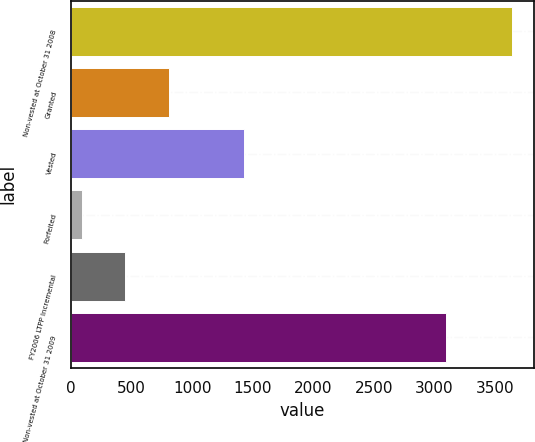<chart> <loc_0><loc_0><loc_500><loc_500><bar_chart><fcel>Non-vested at October 31 2008<fcel>Granted<fcel>Vested<fcel>Forfeited<fcel>FY2006 LTPP Incremental<fcel>Non-vested at October 31 2009<nl><fcel>3640<fcel>807<fcel>1426<fcel>90<fcel>445<fcel>3092<nl></chart> 